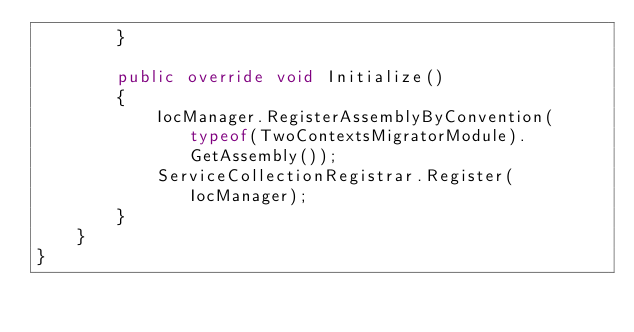Convert code to text. <code><loc_0><loc_0><loc_500><loc_500><_C#_>        }

        public override void Initialize()
        {
            IocManager.RegisterAssemblyByConvention(typeof(TwoContextsMigratorModule).GetAssembly());
            ServiceCollectionRegistrar.Register(IocManager);
        }
    }
}
</code> 